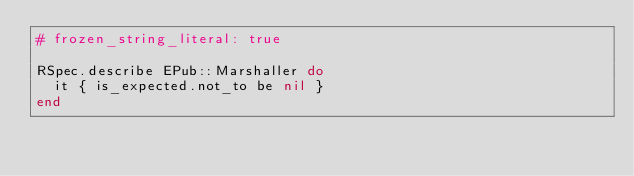<code> <loc_0><loc_0><loc_500><loc_500><_Ruby_># frozen_string_literal: true

RSpec.describe EPub::Marshaller do
  it { is_expected.not_to be nil }
end
</code> 